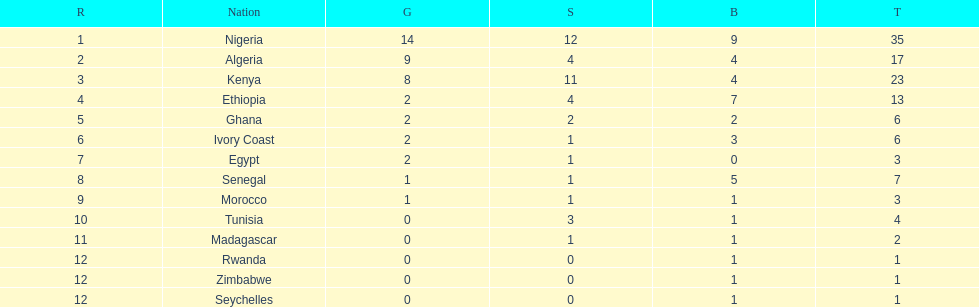How long is the list of countries that won any medals? 14. 